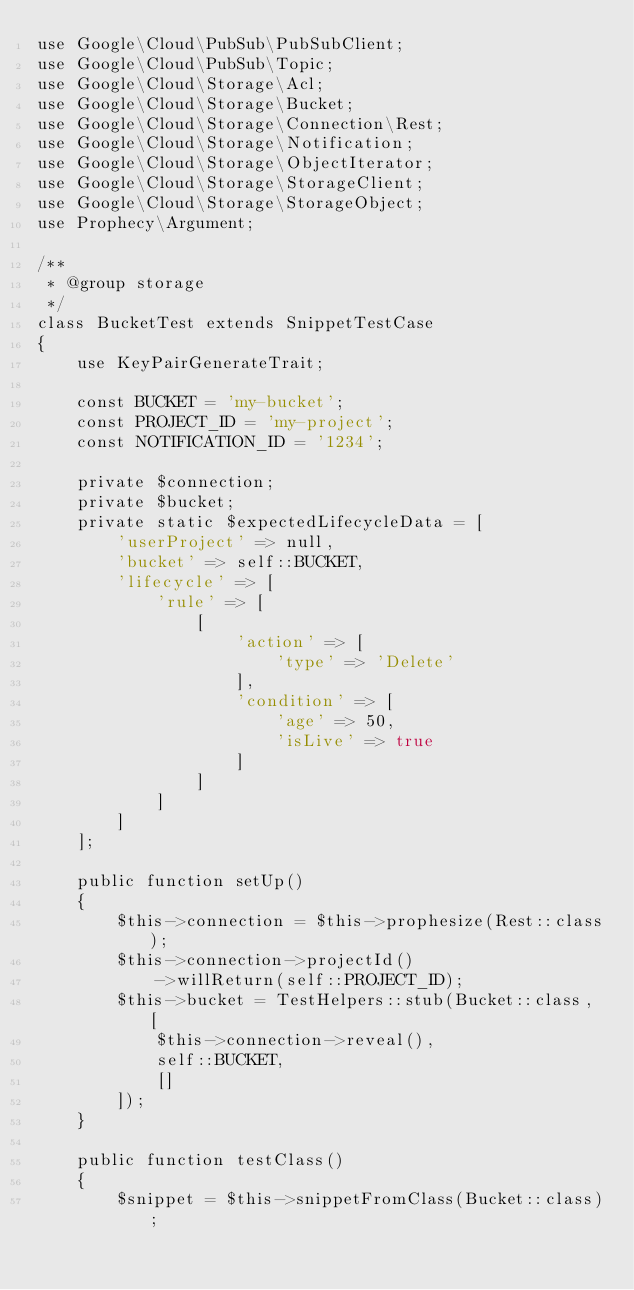<code> <loc_0><loc_0><loc_500><loc_500><_PHP_>use Google\Cloud\PubSub\PubSubClient;
use Google\Cloud\PubSub\Topic;
use Google\Cloud\Storage\Acl;
use Google\Cloud\Storage\Bucket;
use Google\Cloud\Storage\Connection\Rest;
use Google\Cloud\Storage\Notification;
use Google\Cloud\Storage\ObjectIterator;
use Google\Cloud\Storage\StorageClient;
use Google\Cloud\Storage\StorageObject;
use Prophecy\Argument;

/**
 * @group storage
 */
class BucketTest extends SnippetTestCase
{
    use KeyPairGenerateTrait;

    const BUCKET = 'my-bucket';
    const PROJECT_ID = 'my-project';
    const NOTIFICATION_ID = '1234';

    private $connection;
    private $bucket;
    private static $expectedLifecycleData = [
        'userProject' => null,
        'bucket' => self::BUCKET,
        'lifecycle' => [
            'rule' => [
                [
                    'action' => [
                        'type' => 'Delete'
                    ],
                    'condition' => [
                        'age' => 50,
                        'isLive' => true
                    ]
                ]
            ]
        ]
    ];

    public function setUp()
    {
        $this->connection = $this->prophesize(Rest::class);
        $this->connection->projectId()
            ->willReturn(self::PROJECT_ID);
        $this->bucket = TestHelpers::stub(Bucket::class, [
            $this->connection->reveal(),
            self::BUCKET,
            []
        ]);
    }

    public function testClass()
    {
        $snippet = $this->snippetFromClass(Bucket::class);</code> 